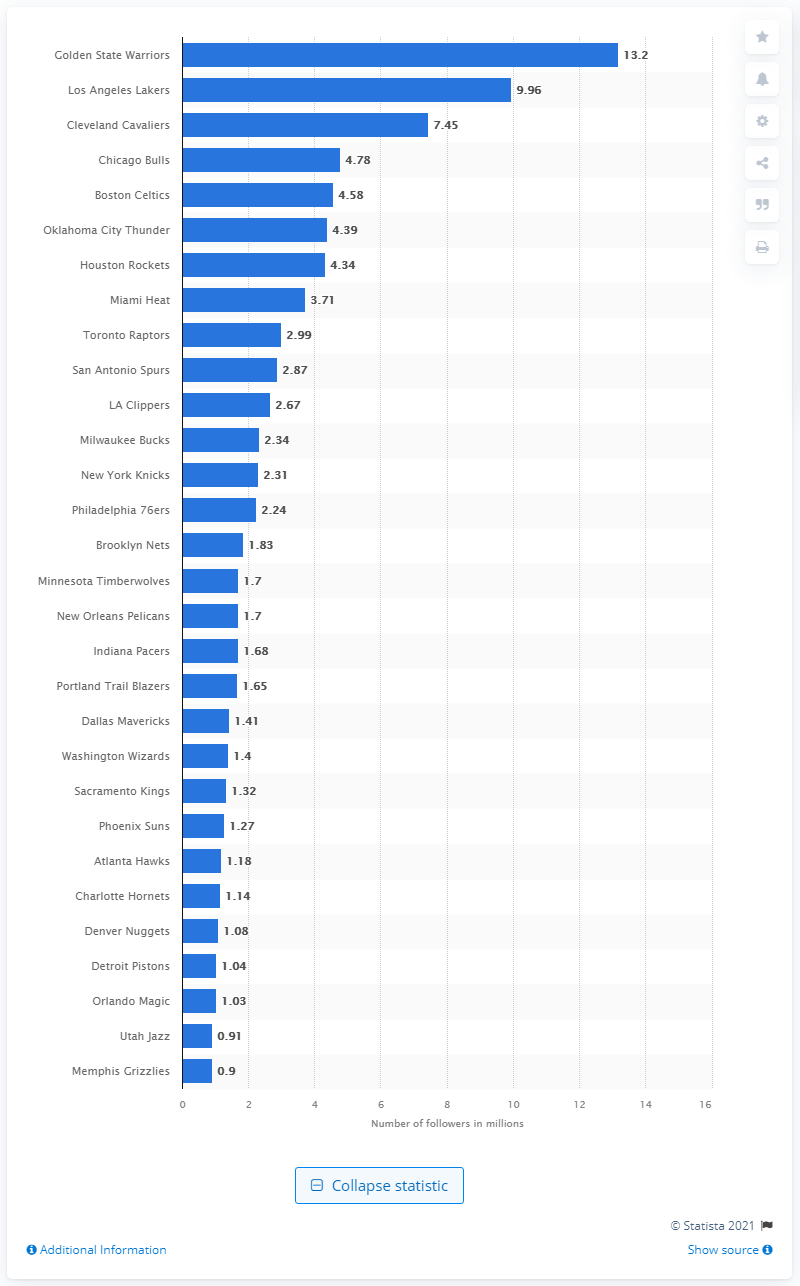Highlight a few significant elements in this photo. The Golden State Warriors had 13.2 followers on Instagram in 2019. 